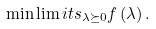<formula> <loc_0><loc_0><loc_500><loc_500>\min \lim i t s _ { { \lambda } \succeq 0 } f \left ( { \lambda } \right ) .</formula> 